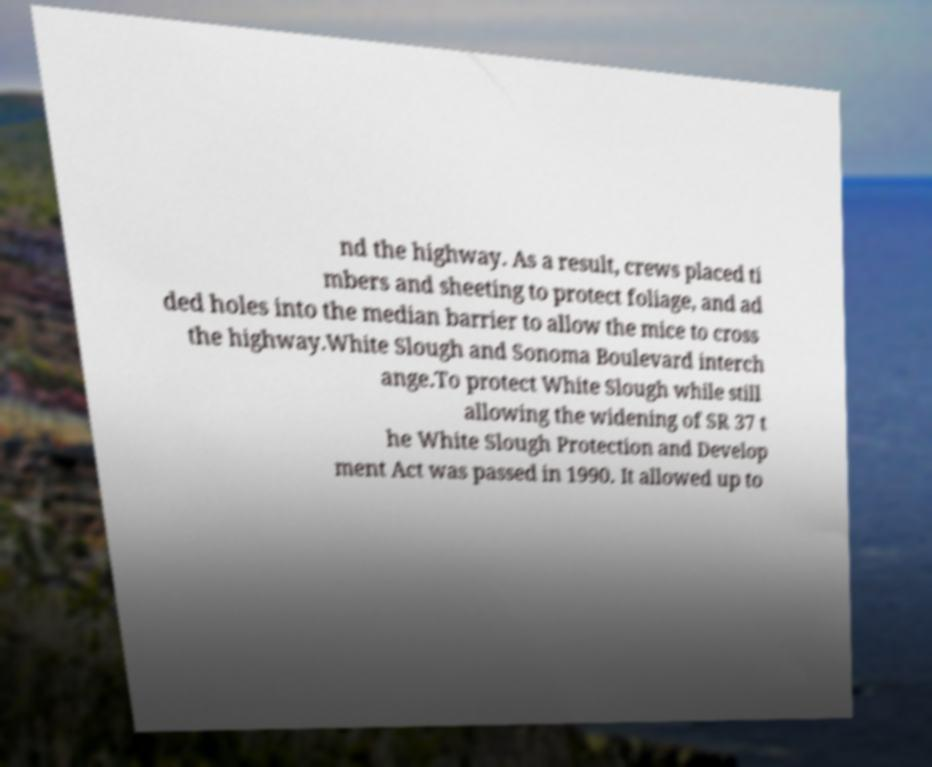Can you read and provide the text displayed in the image?This photo seems to have some interesting text. Can you extract and type it out for me? nd the highway. As a result, crews placed ti mbers and sheeting to protect foliage, and ad ded holes into the median barrier to allow the mice to cross the highway.White Slough and Sonoma Boulevard interch ange.To protect White Slough while still allowing the widening of SR 37 t he White Slough Protection and Develop ment Act was passed in 1990. It allowed up to 